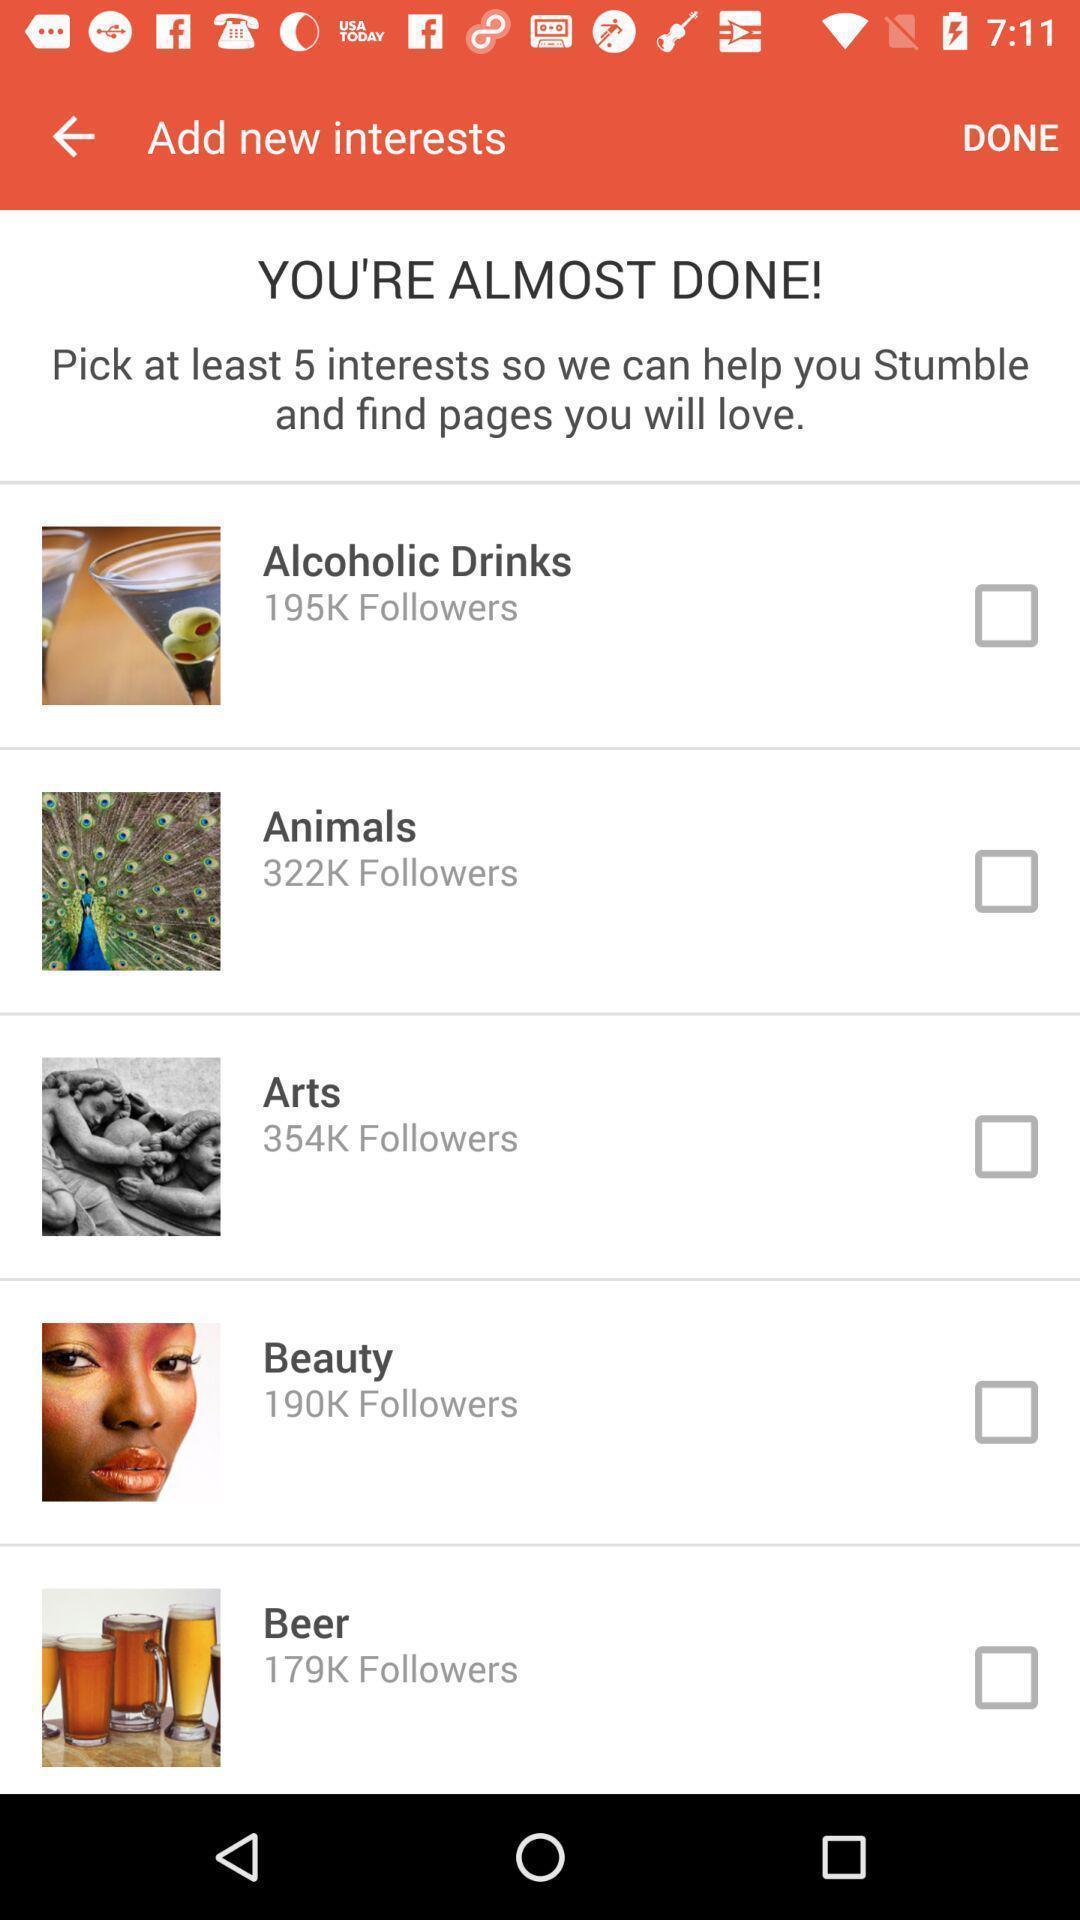Provide a description of this screenshot. Page showing the list of interests. 